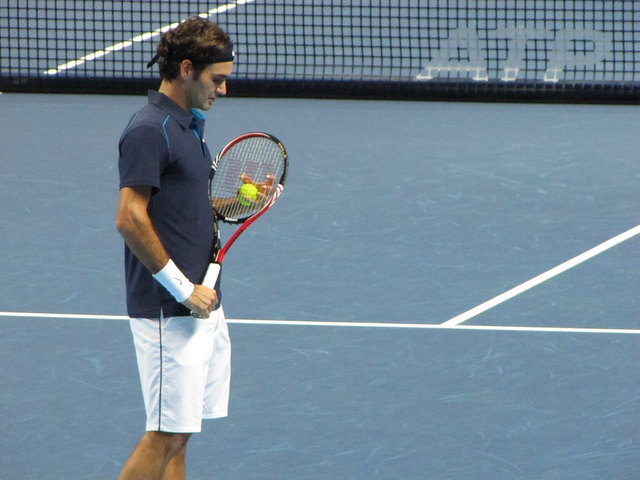Describe the objects in this image and their specific colors. I can see people in gray, white, and black tones, tennis racket in gray, darkgray, and black tones, and sports ball in gray, yellow, khaki, and olive tones in this image. 